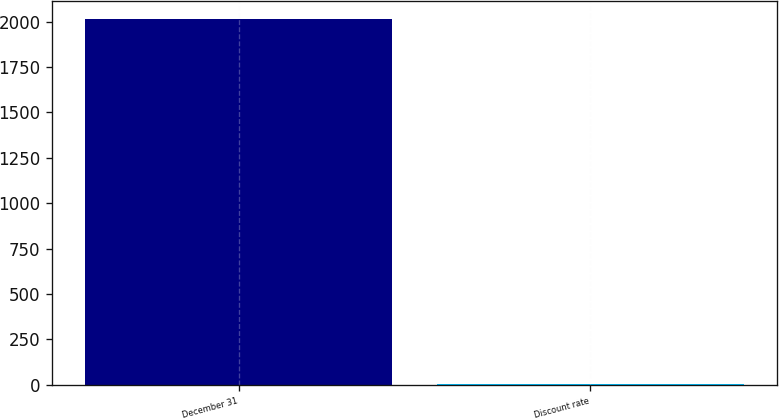Convert chart. <chart><loc_0><loc_0><loc_500><loc_500><bar_chart><fcel>December 31<fcel>Discount rate<nl><fcel>2015<fcel>4<nl></chart> 